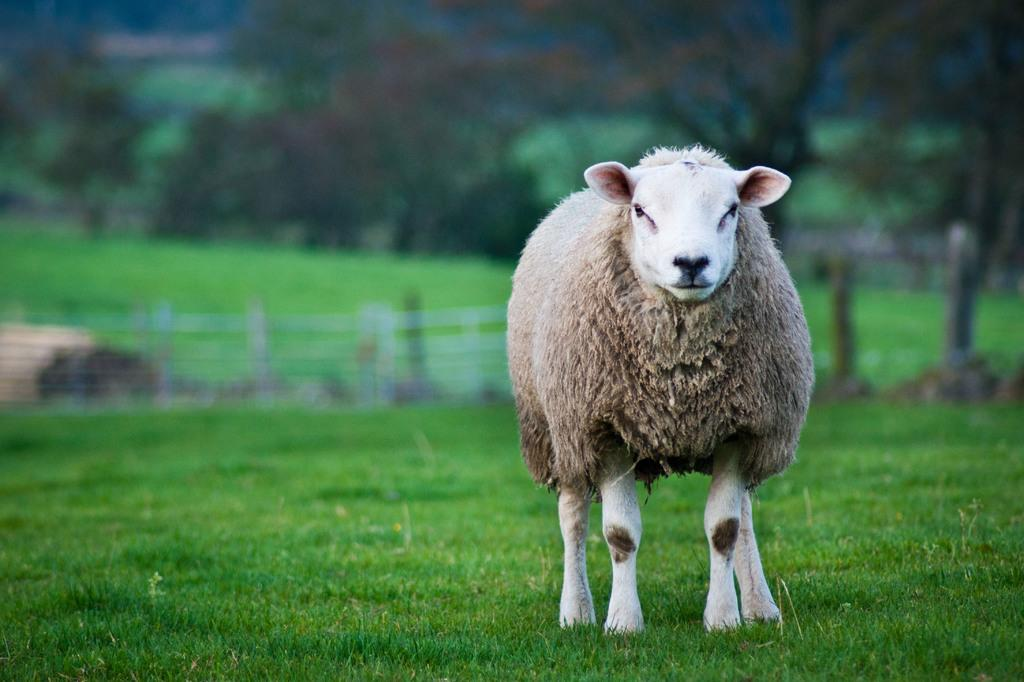What animals are in the image? There are sheep in the image. Where are the sheep located? The sheep are on the grass. Can you describe the background of the image? The background of the image is blurry. What can be seen in the background of the image? There is a fence and trees visible in the background. What scent is being protested by the sheep in the image? There is no indication in the image that the sheep are protesting any scent or anything else. 